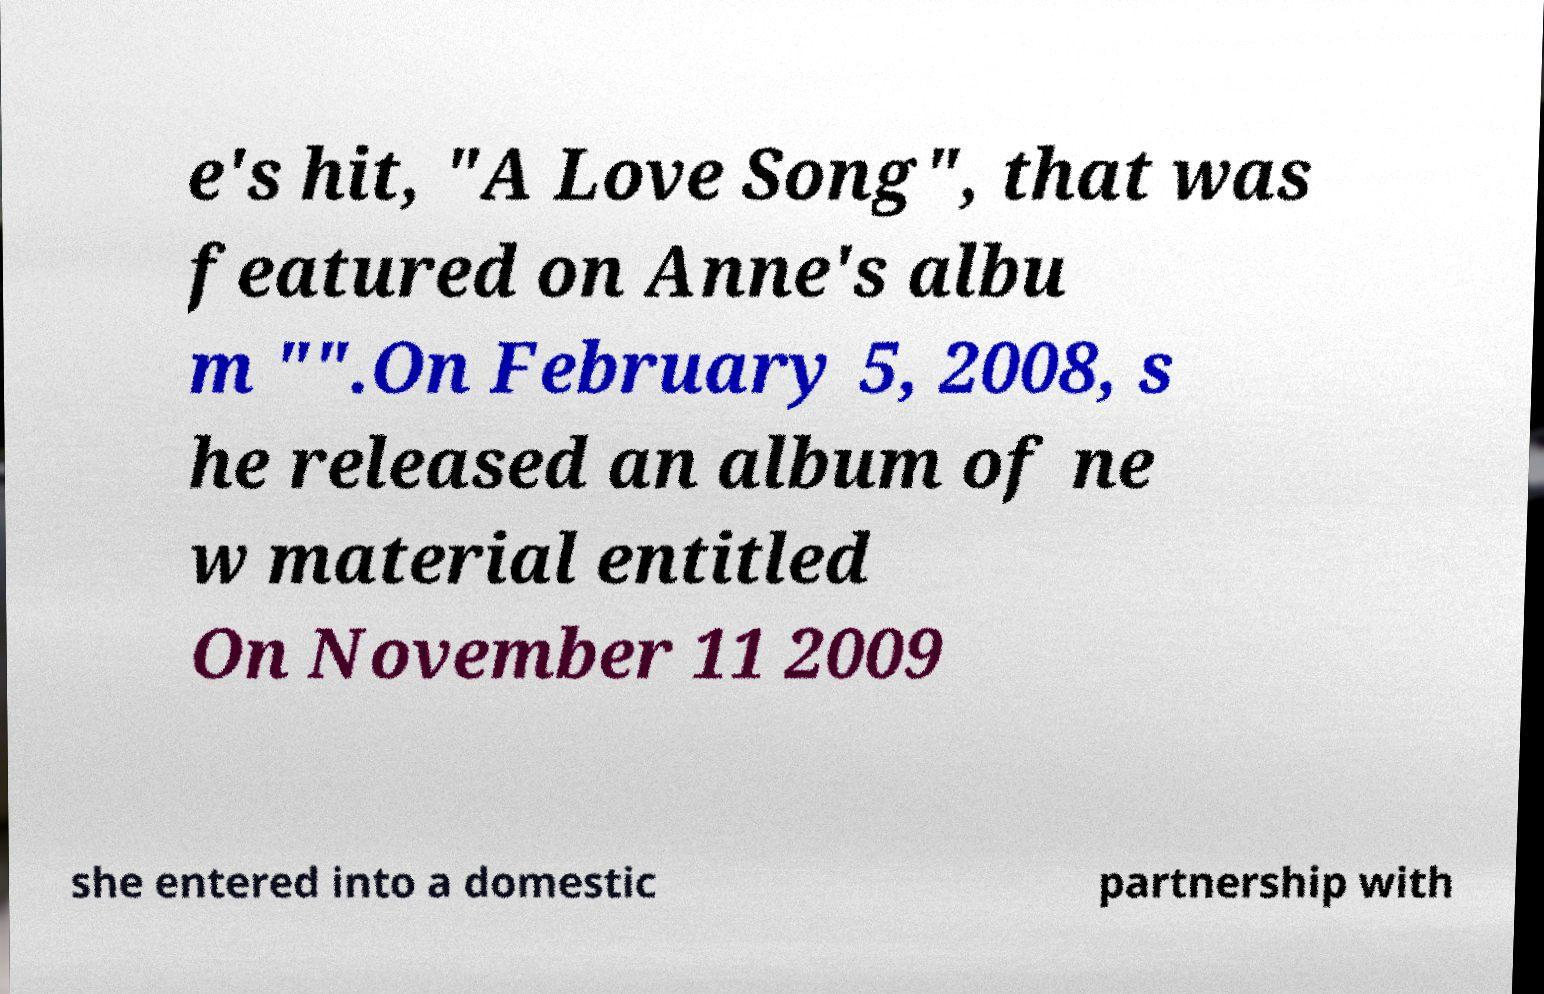I need the written content from this picture converted into text. Can you do that? e's hit, "A Love Song", that was featured on Anne's albu m "".On February 5, 2008, s he released an album of ne w material entitled On November 11 2009 she entered into a domestic partnership with 